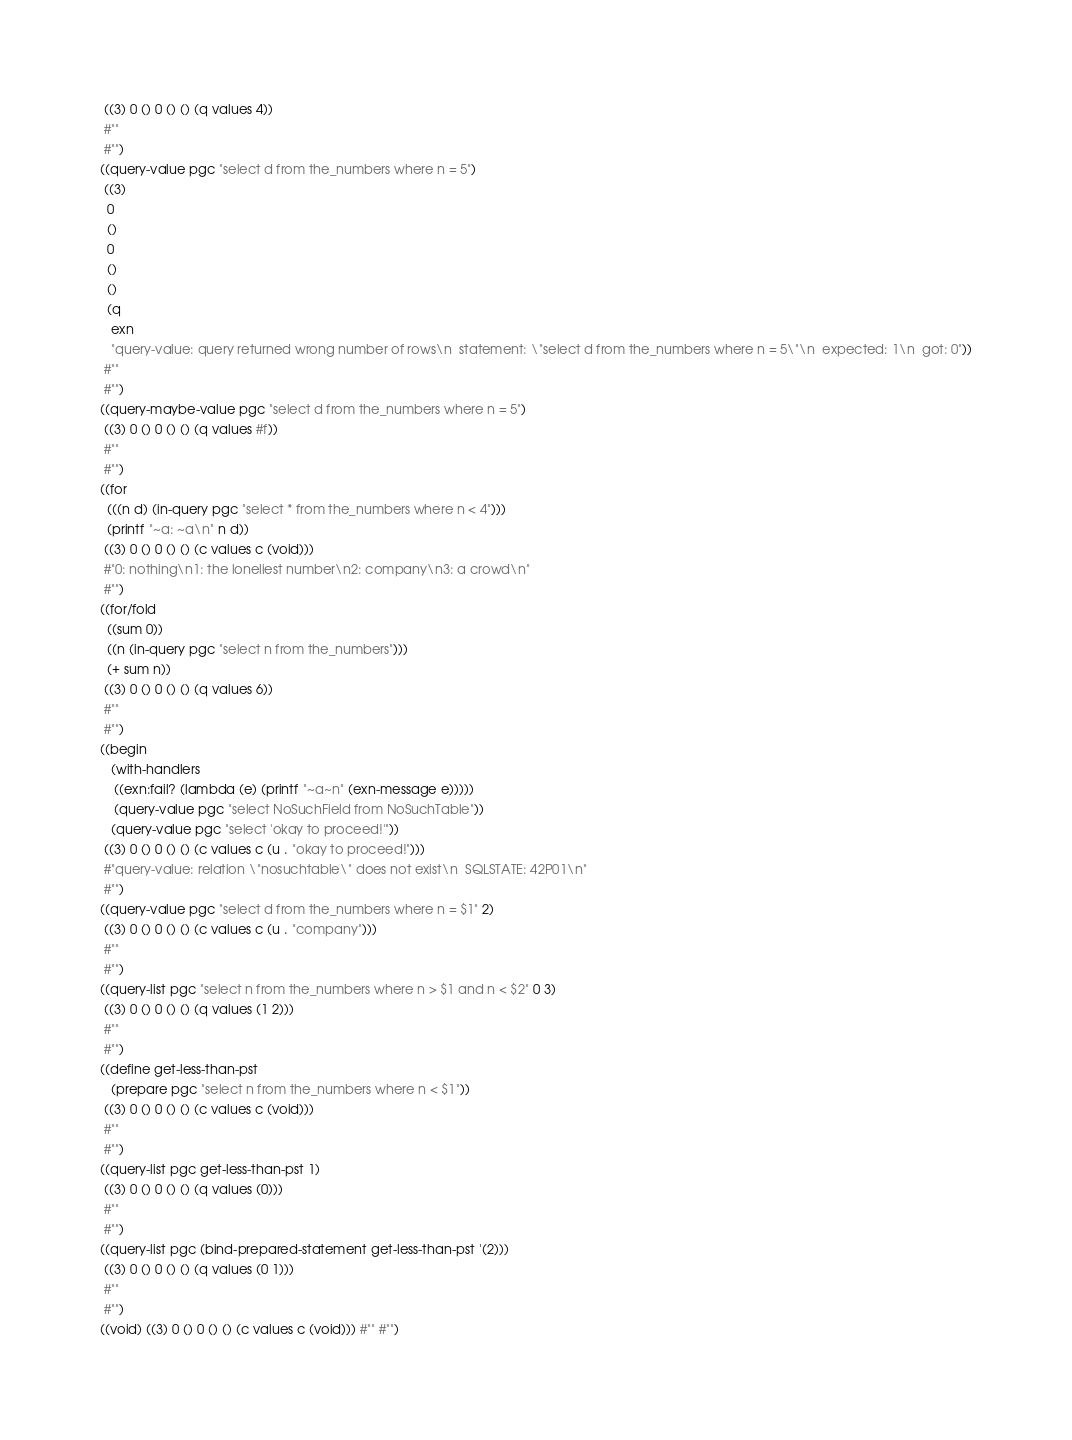Convert code to text. <code><loc_0><loc_0><loc_500><loc_500><_Racket_> ((3) 0 () 0 () () (q values 4))
 #""
 #"")
((query-value pgc "select d from the_numbers where n = 5")
 ((3)
  0
  ()
  0
  ()
  ()
  (q
   exn
   "query-value: query returned wrong number of rows\n  statement: \"select d from the_numbers where n = 5\"\n  expected: 1\n  got: 0"))
 #""
 #"")
((query-maybe-value pgc "select d from the_numbers where n = 5")
 ((3) 0 () 0 () () (q values #f))
 #""
 #"")
((for
  (((n d) (in-query pgc "select * from the_numbers where n < 4")))
  (printf "~a: ~a\n" n d))
 ((3) 0 () 0 () () (c values c (void)))
 #"0: nothing\n1: the loneliest number\n2: company\n3: a crowd\n"
 #"")
((for/fold
  ((sum 0))
  ((n (in-query pgc "select n from the_numbers")))
  (+ sum n))
 ((3) 0 () 0 () () (q values 6))
 #""
 #"")
((begin
   (with-handlers
    ((exn:fail? (lambda (e) (printf "~a~n" (exn-message e)))))
    (query-value pgc "select NoSuchField from NoSuchTable"))
   (query-value pgc "select 'okay to proceed!'"))
 ((3) 0 () 0 () () (c values c (u . "okay to proceed!")))
 #"query-value: relation \"nosuchtable\" does not exist\n  SQLSTATE: 42P01\n"
 #"")
((query-value pgc "select d from the_numbers where n = $1" 2)
 ((3) 0 () 0 () () (c values c (u . "company")))
 #""
 #"")
((query-list pgc "select n from the_numbers where n > $1 and n < $2" 0 3)
 ((3) 0 () 0 () () (q values (1 2)))
 #""
 #"")
((define get-less-than-pst
   (prepare pgc "select n from the_numbers where n < $1"))
 ((3) 0 () 0 () () (c values c (void)))
 #""
 #"")
((query-list pgc get-less-than-pst 1)
 ((3) 0 () 0 () () (q values (0)))
 #""
 #"")
((query-list pgc (bind-prepared-statement get-less-than-pst '(2)))
 ((3) 0 () 0 () () (q values (0 1)))
 #""
 #"")
((void) ((3) 0 () 0 () () (c values c (void))) #"" #"")
</code> 